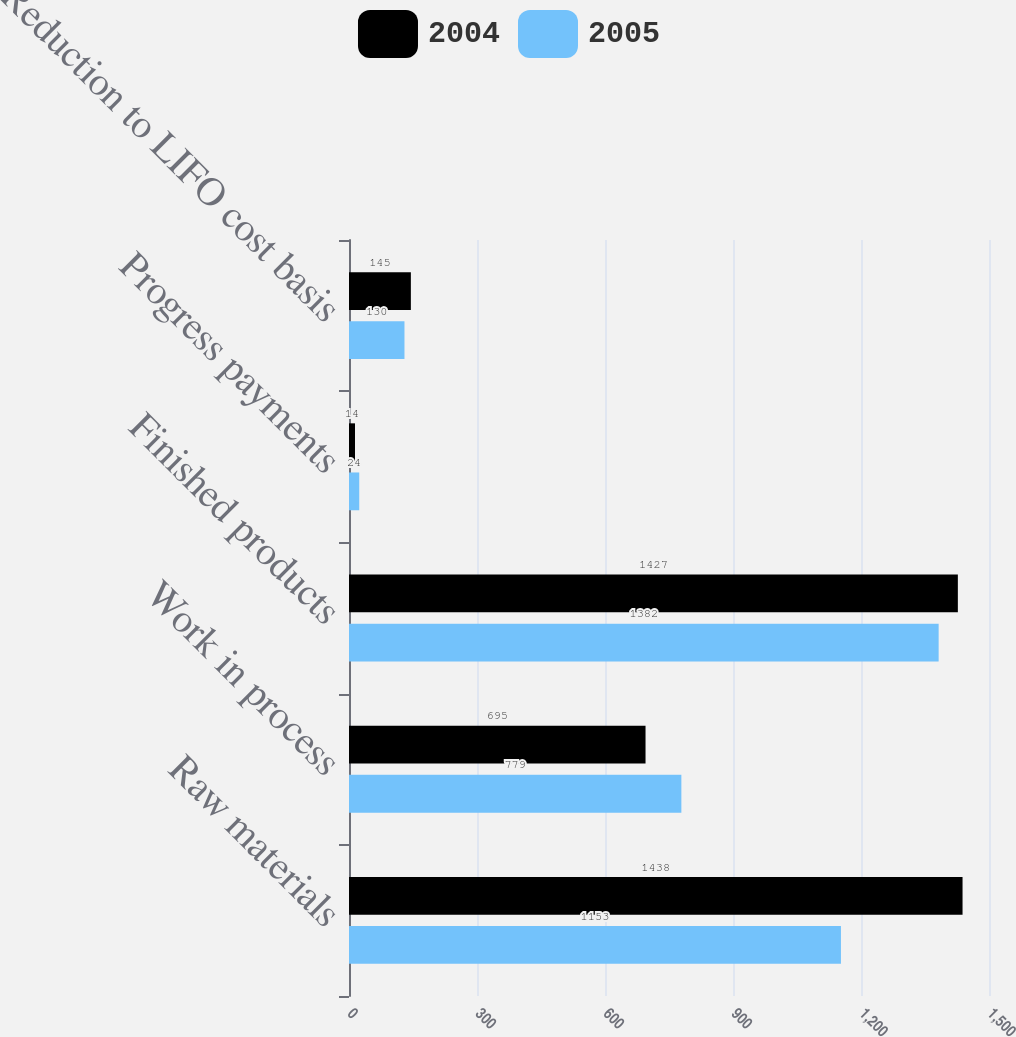<chart> <loc_0><loc_0><loc_500><loc_500><stacked_bar_chart><ecel><fcel>Raw materials<fcel>Work in process<fcel>Finished products<fcel>Progress payments<fcel>Reduction to LIFO cost basis<nl><fcel>2004<fcel>1438<fcel>695<fcel>1427<fcel>14<fcel>145<nl><fcel>2005<fcel>1153<fcel>779<fcel>1382<fcel>24<fcel>130<nl></chart> 